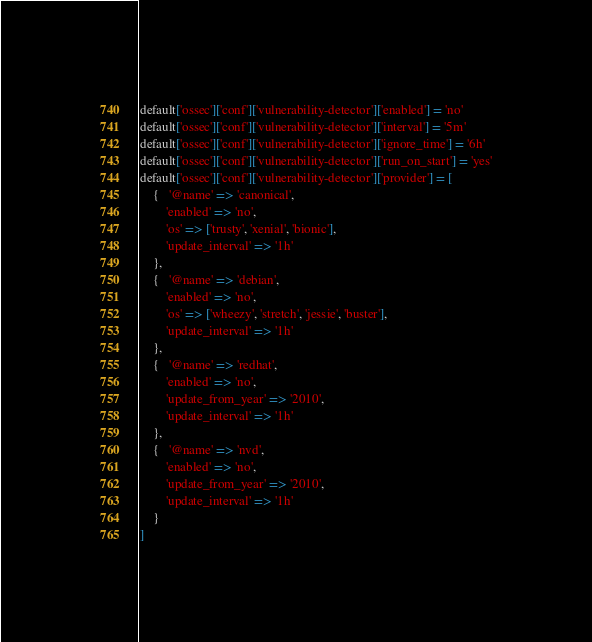Convert code to text. <code><loc_0><loc_0><loc_500><loc_500><_Ruby_>default['ossec']['conf']['vulnerability-detector']['enabled'] = 'no'
default['ossec']['conf']['vulnerability-detector']['interval'] = '5m'
default['ossec']['conf']['vulnerability-detector']['ignore_time'] = '6h'
default['ossec']['conf']['vulnerability-detector']['run_on_start'] = 'yes'
default['ossec']['conf']['vulnerability-detector']['provider'] = [
    {   '@name' => 'canonical',
        'enabled' => 'no',
        'os' => ['trusty', 'xenial', 'bionic'],
        'update_interval' => '1h'
    },
    {   '@name' => 'debian',
        'enabled' => 'no',
        'os' => ['wheezy', 'stretch', 'jessie', 'buster'],
        'update_interval' => '1h'
    },
    {   '@name' => 'redhat',
        'enabled' => 'no',
        'update_from_year' => '2010',
        'update_interval' => '1h'
    },
    {   '@name' => 'nvd',
        'enabled' => 'no',
        'update_from_year' => '2010',
        'update_interval' => '1h'
    }
]</code> 